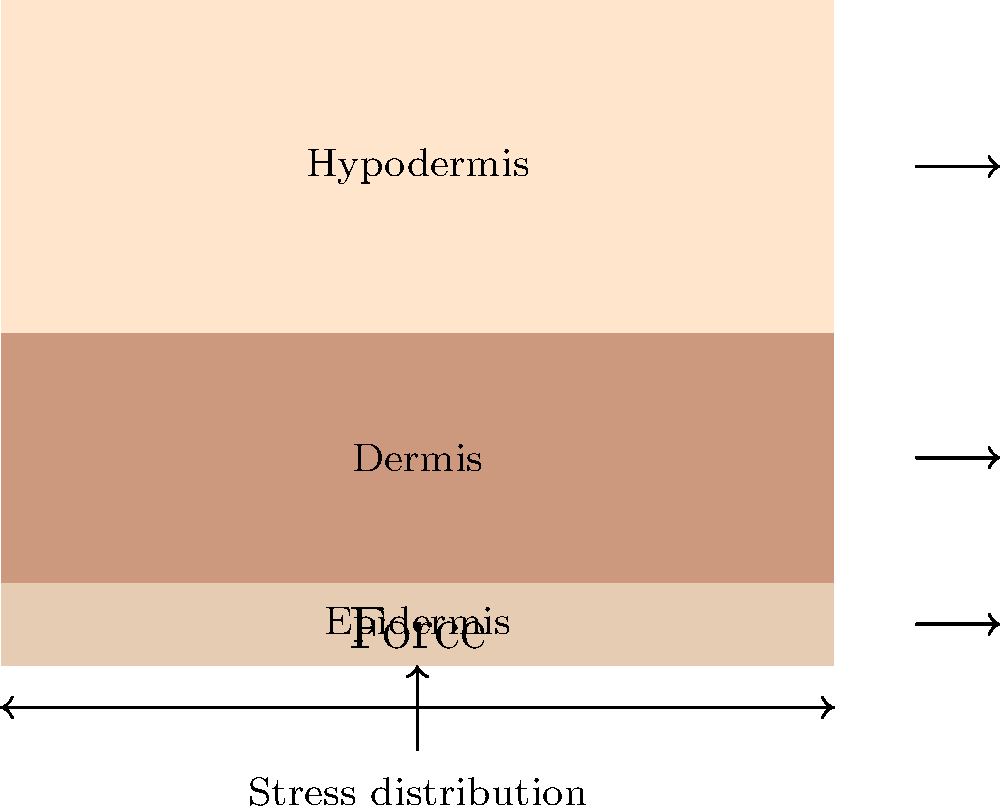Considering the cross-sectional diagram of skin layers, which layer is primarily responsible for the skin's ability to withstand mechanical stress from frequent makeup application and removal? To answer this question, let's analyze the biomechanical properties of each skin layer:

1. Epidermis (top layer):
   - Thin and primarily composed of keratinocytes
   - Provides barrier function but has limited mechanical strength

2. Dermis (middle layer):
   - Thicker than the epidermis
   - Contains collagen and elastin fibers
   - Responsible for skin's elasticity and strength

3. Hypodermis (bottom layer):
   - Composed mainly of adipose tissue
   - Provides insulation and cushioning, but not significant mechanical strength

The dermis is the layer primarily responsible for the skin's ability to withstand mechanical stress due to its composition and structure:

a) Collagen fibers: Provide tensile strength and resist deformation
b) Elastin fibers: Allow the skin to return to its original shape after stretching
c) Ground substance: Helps distribute mechanical forces throughout the tissue

When makeup is applied and removed frequently, the skin experiences repeated mechanical stress. The dermis, with its network of collagen and elastin fibers, provides the necessary strength and elasticity to withstand these forces without damage.

The epidermis, while important for barrier function, is too thin to provide significant mechanical strength. The hypodermis, being mostly fatty tissue, does not contribute significantly to mechanical resistance.
Answer: Dermis 